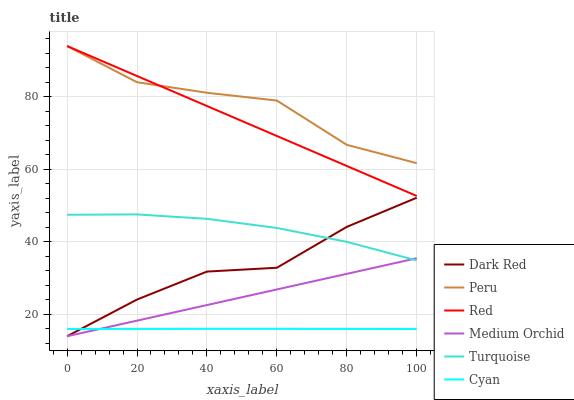Does Cyan have the minimum area under the curve?
Answer yes or no. Yes. Does Peru have the maximum area under the curve?
Answer yes or no. Yes. Does Dark Red have the minimum area under the curve?
Answer yes or no. No. Does Dark Red have the maximum area under the curve?
Answer yes or no. No. Is Medium Orchid the smoothest?
Answer yes or no. Yes. Is Peru the roughest?
Answer yes or no. Yes. Is Dark Red the smoothest?
Answer yes or no. No. Is Dark Red the roughest?
Answer yes or no. No. Does Dark Red have the lowest value?
Answer yes or no. Yes. Does Peru have the lowest value?
Answer yes or no. No. Does Red have the highest value?
Answer yes or no. Yes. Does Dark Red have the highest value?
Answer yes or no. No. Is Dark Red less than Red?
Answer yes or no. Yes. Is Peru greater than Cyan?
Answer yes or no. Yes. Does Cyan intersect Dark Red?
Answer yes or no. Yes. Is Cyan less than Dark Red?
Answer yes or no. No. Is Cyan greater than Dark Red?
Answer yes or no. No. Does Dark Red intersect Red?
Answer yes or no. No. 